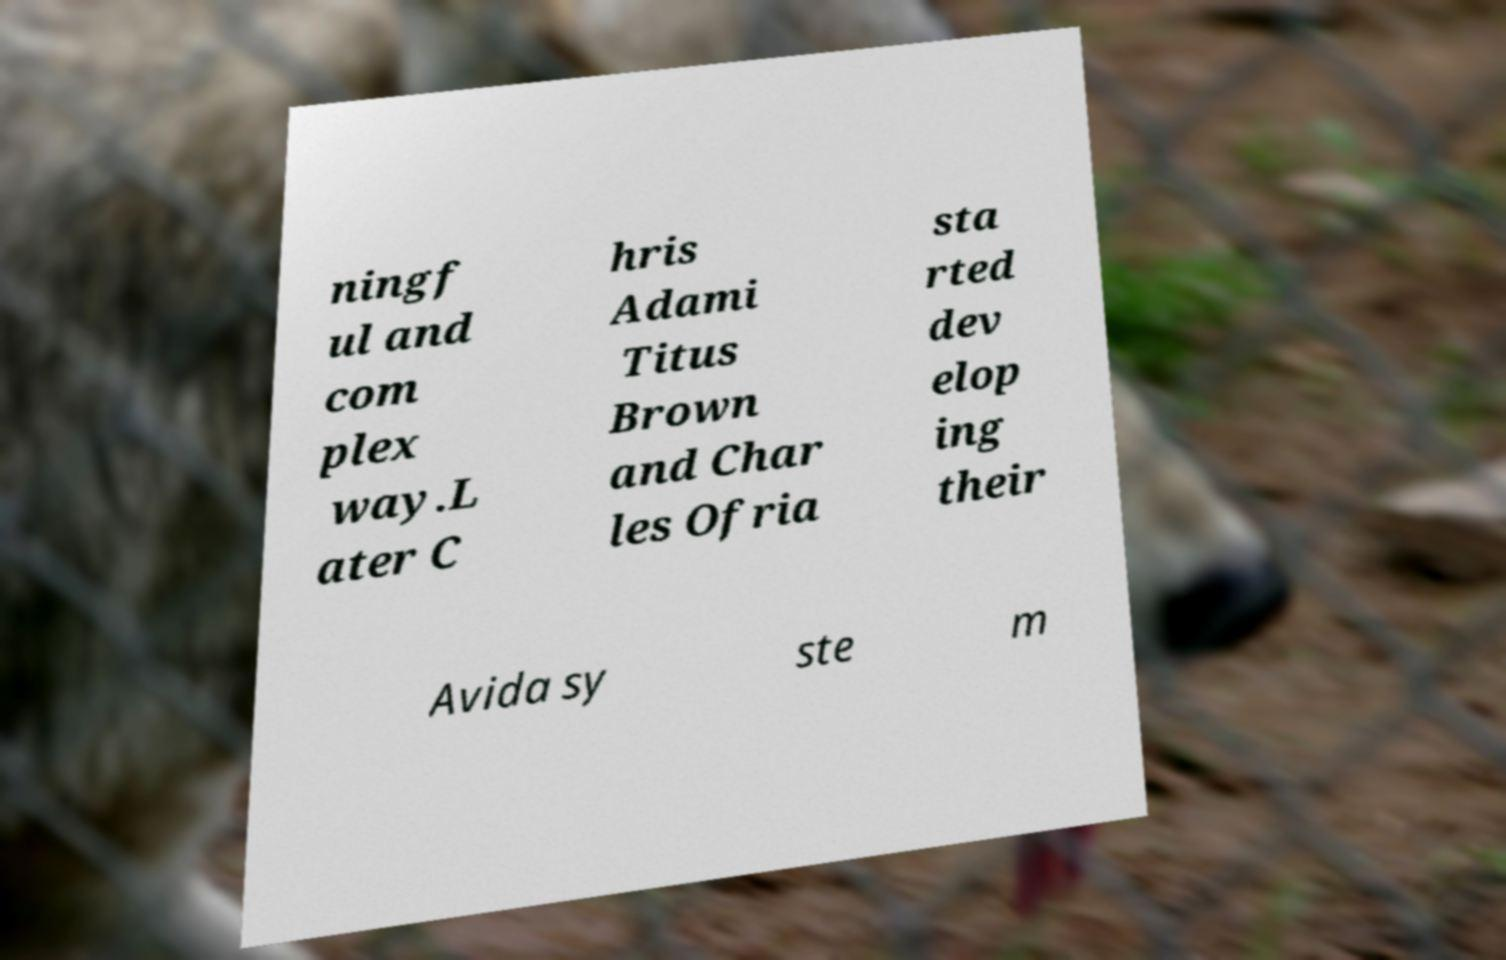There's text embedded in this image that I need extracted. Can you transcribe it verbatim? ningf ul and com plex way.L ater C hris Adami Titus Brown and Char les Ofria sta rted dev elop ing their Avida sy ste m 